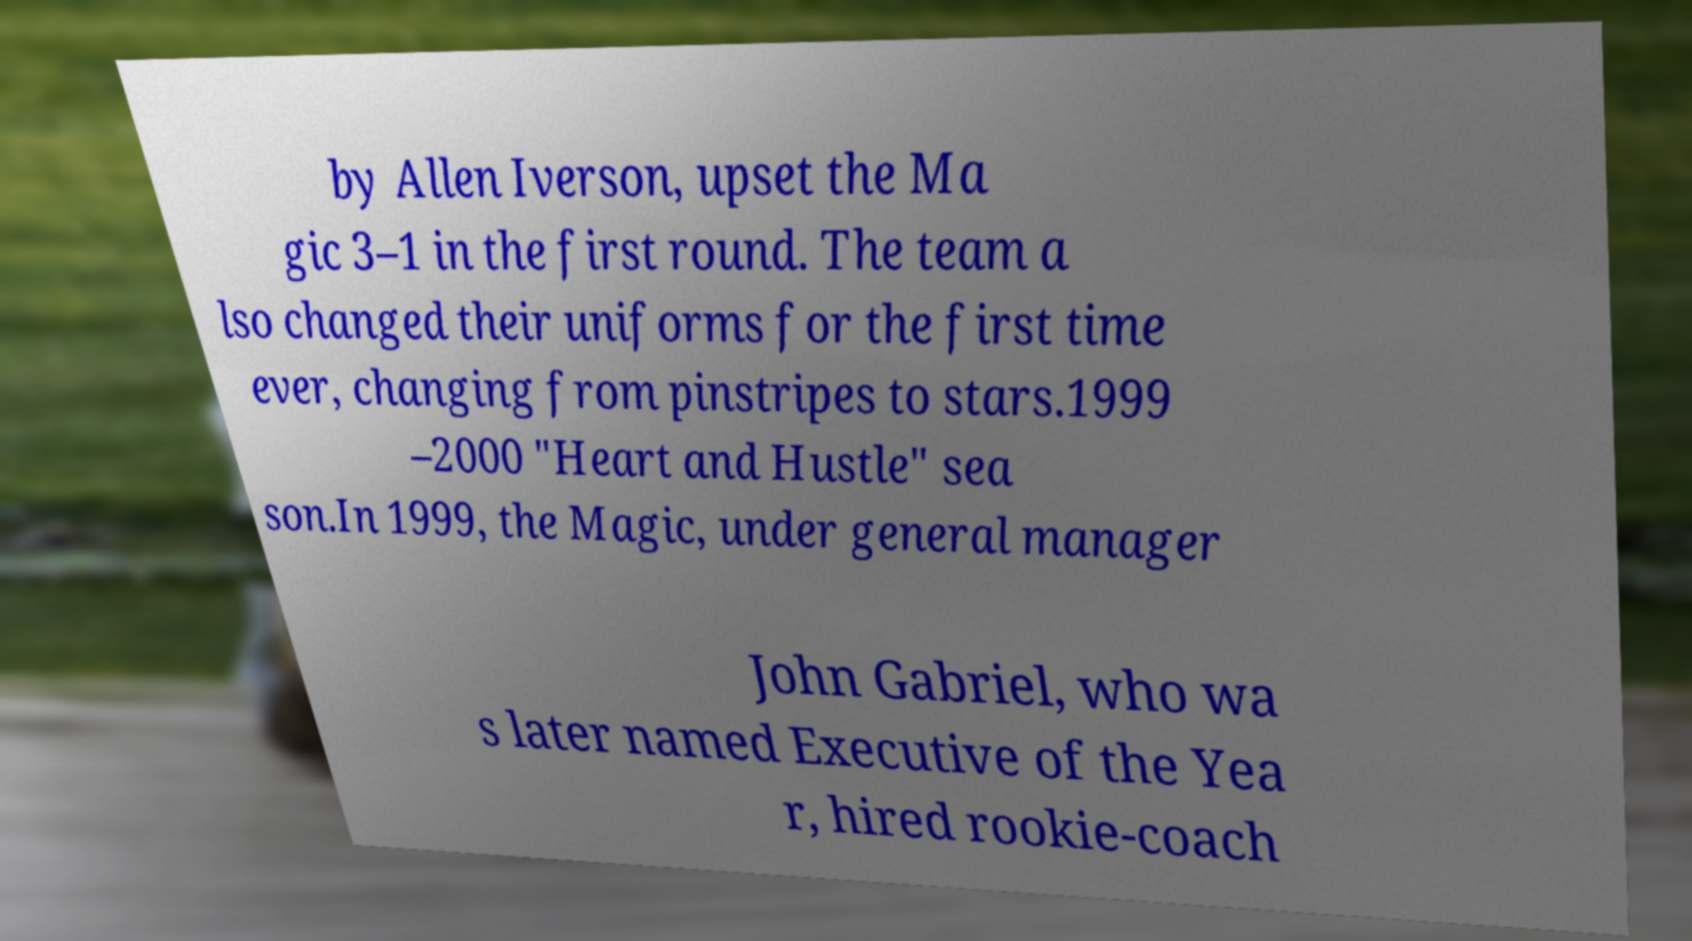Could you extract and type out the text from this image? by Allen Iverson, upset the Ma gic 3–1 in the first round. The team a lso changed their uniforms for the first time ever, changing from pinstripes to stars.1999 –2000 "Heart and Hustle" sea son.In 1999, the Magic, under general manager John Gabriel, who wa s later named Executive of the Yea r, hired rookie-coach 